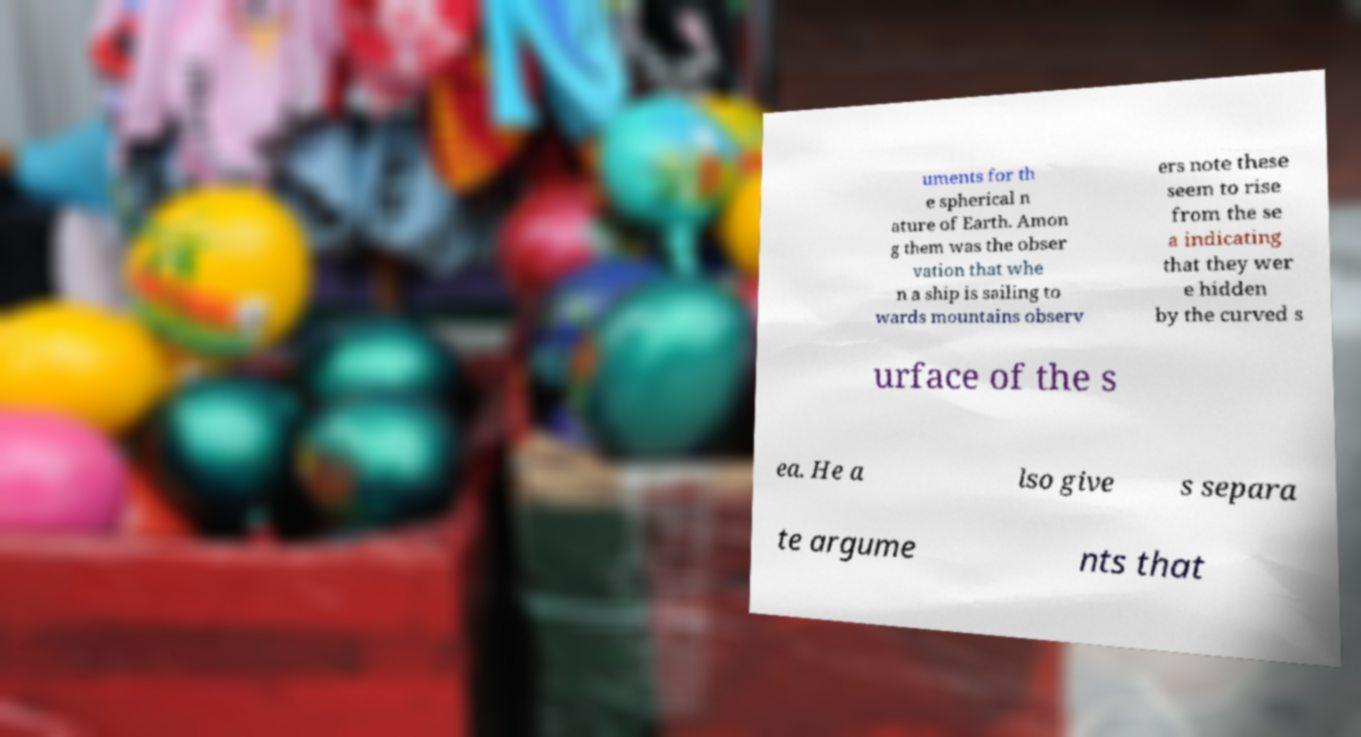Could you extract and type out the text from this image? uments for th e spherical n ature of Earth. Amon g them was the obser vation that whe n a ship is sailing to wards mountains observ ers note these seem to rise from the se a indicating that they wer e hidden by the curved s urface of the s ea. He a lso give s separa te argume nts that 